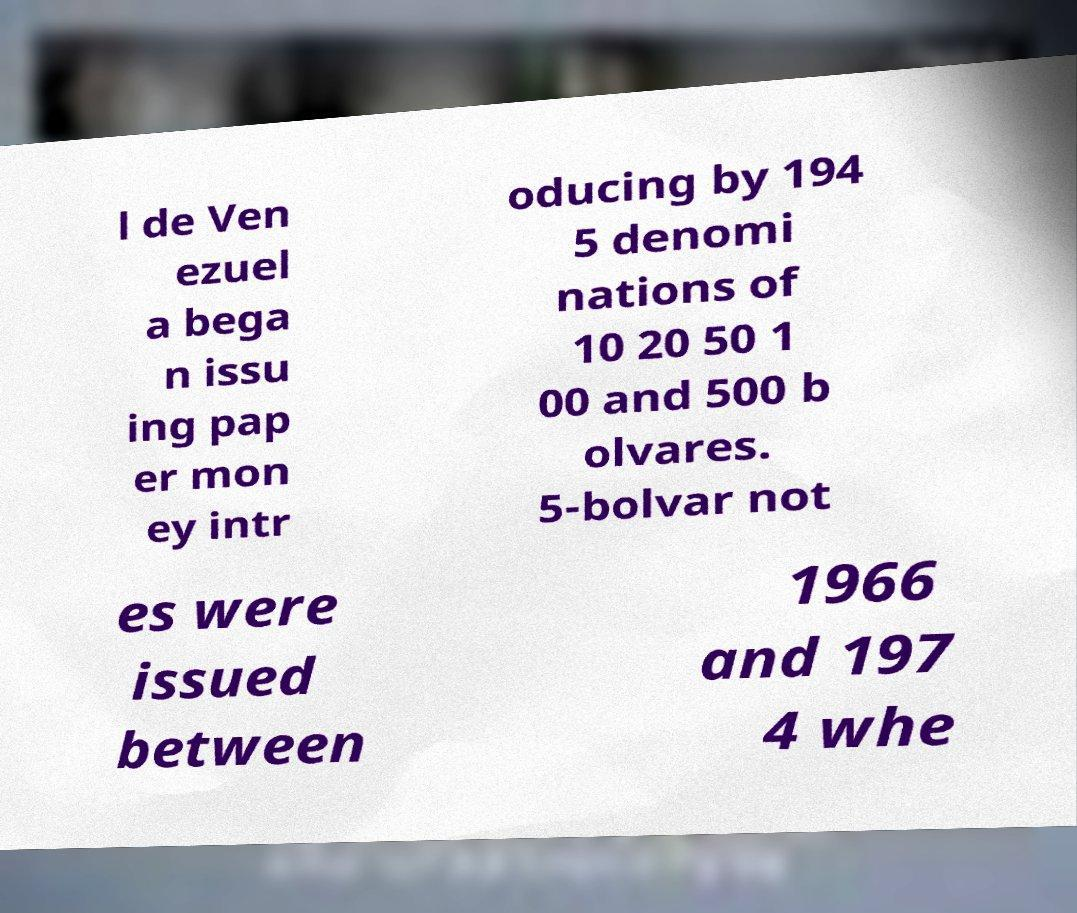Can you accurately transcribe the text from the provided image for me? l de Ven ezuel a bega n issu ing pap er mon ey intr oducing by 194 5 denomi nations of 10 20 50 1 00 and 500 b olvares. 5-bolvar not es were issued between 1966 and 197 4 whe 